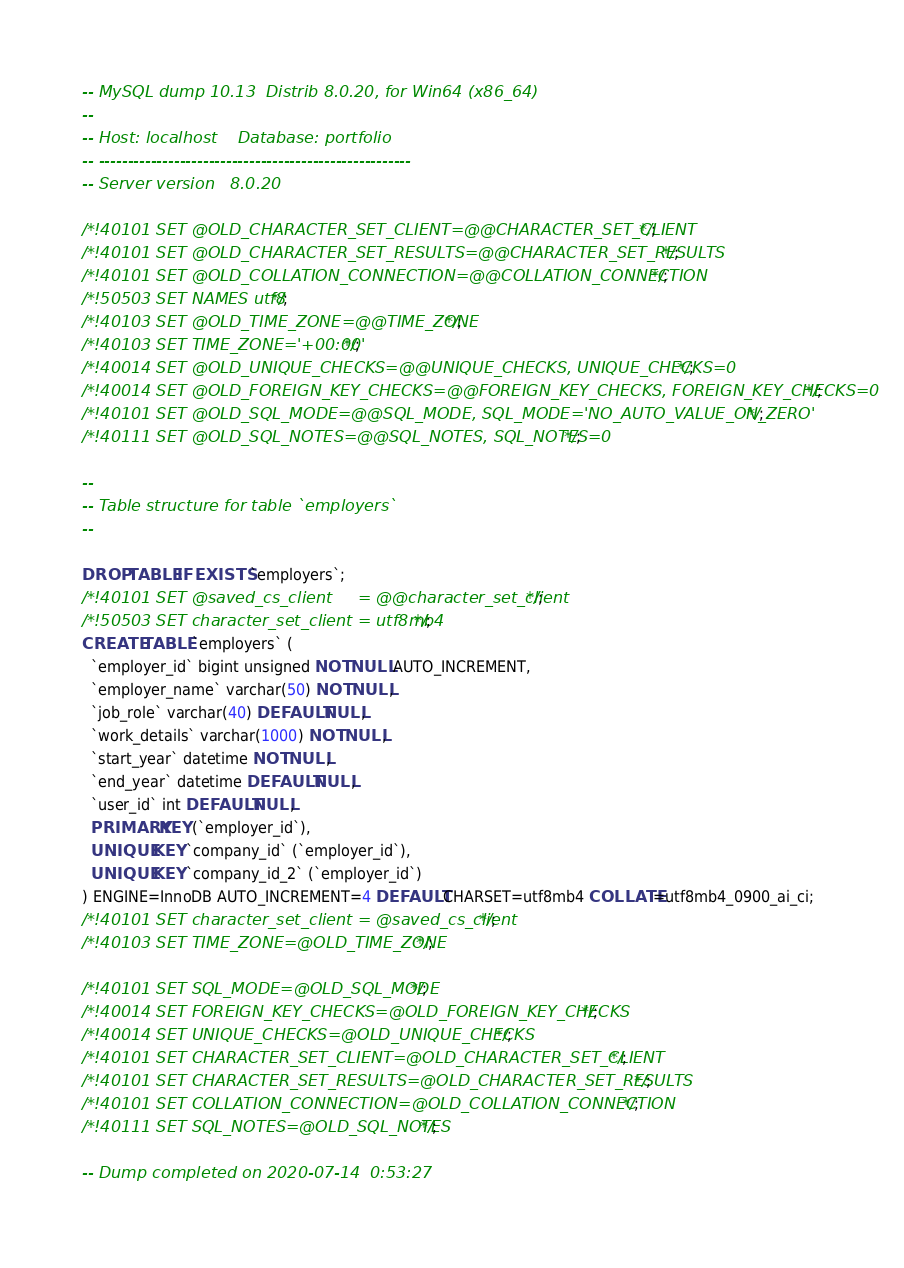Convert code to text. <code><loc_0><loc_0><loc_500><loc_500><_SQL_>-- MySQL dump 10.13  Distrib 8.0.20, for Win64 (x86_64)
--
-- Host: localhost    Database: portfolio
-- ------------------------------------------------------
-- Server version	8.0.20

/*!40101 SET @OLD_CHARACTER_SET_CLIENT=@@CHARACTER_SET_CLIENT */;
/*!40101 SET @OLD_CHARACTER_SET_RESULTS=@@CHARACTER_SET_RESULTS */;
/*!40101 SET @OLD_COLLATION_CONNECTION=@@COLLATION_CONNECTION */;
/*!50503 SET NAMES utf8 */;
/*!40103 SET @OLD_TIME_ZONE=@@TIME_ZONE */;
/*!40103 SET TIME_ZONE='+00:00' */;
/*!40014 SET @OLD_UNIQUE_CHECKS=@@UNIQUE_CHECKS, UNIQUE_CHECKS=0 */;
/*!40014 SET @OLD_FOREIGN_KEY_CHECKS=@@FOREIGN_KEY_CHECKS, FOREIGN_KEY_CHECKS=0 */;
/*!40101 SET @OLD_SQL_MODE=@@SQL_MODE, SQL_MODE='NO_AUTO_VALUE_ON_ZERO' */;
/*!40111 SET @OLD_SQL_NOTES=@@SQL_NOTES, SQL_NOTES=0 */;

--
-- Table structure for table `employers`
--

DROP TABLE IF EXISTS `employers`;
/*!40101 SET @saved_cs_client     = @@character_set_client */;
/*!50503 SET character_set_client = utf8mb4 */;
CREATE TABLE `employers` (
  `employer_id` bigint unsigned NOT NULL AUTO_INCREMENT,
  `employer_name` varchar(50) NOT NULL,
  `job_role` varchar(40) DEFAULT NULL,
  `work_details` varchar(1000) NOT NULL,
  `start_year` datetime NOT NULL,
  `end_year` datetime DEFAULT NULL,
  `user_id` int DEFAULT NULL,
  PRIMARY KEY (`employer_id`),
  UNIQUE KEY `company_id` (`employer_id`),
  UNIQUE KEY `company_id_2` (`employer_id`)
) ENGINE=InnoDB AUTO_INCREMENT=4 DEFAULT CHARSET=utf8mb4 COLLATE=utf8mb4_0900_ai_ci;
/*!40101 SET character_set_client = @saved_cs_client */;
/*!40103 SET TIME_ZONE=@OLD_TIME_ZONE */;

/*!40101 SET SQL_MODE=@OLD_SQL_MODE */;
/*!40014 SET FOREIGN_KEY_CHECKS=@OLD_FOREIGN_KEY_CHECKS */;
/*!40014 SET UNIQUE_CHECKS=@OLD_UNIQUE_CHECKS */;
/*!40101 SET CHARACTER_SET_CLIENT=@OLD_CHARACTER_SET_CLIENT */;
/*!40101 SET CHARACTER_SET_RESULTS=@OLD_CHARACTER_SET_RESULTS */;
/*!40101 SET COLLATION_CONNECTION=@OLD_COLLATION_CONNECTION */;
/*!40111 SET SQL_NOTES=@OLD_SQL_NOTES */;

-- Dump completed on 2020-07-14  0:53:27
</code> 